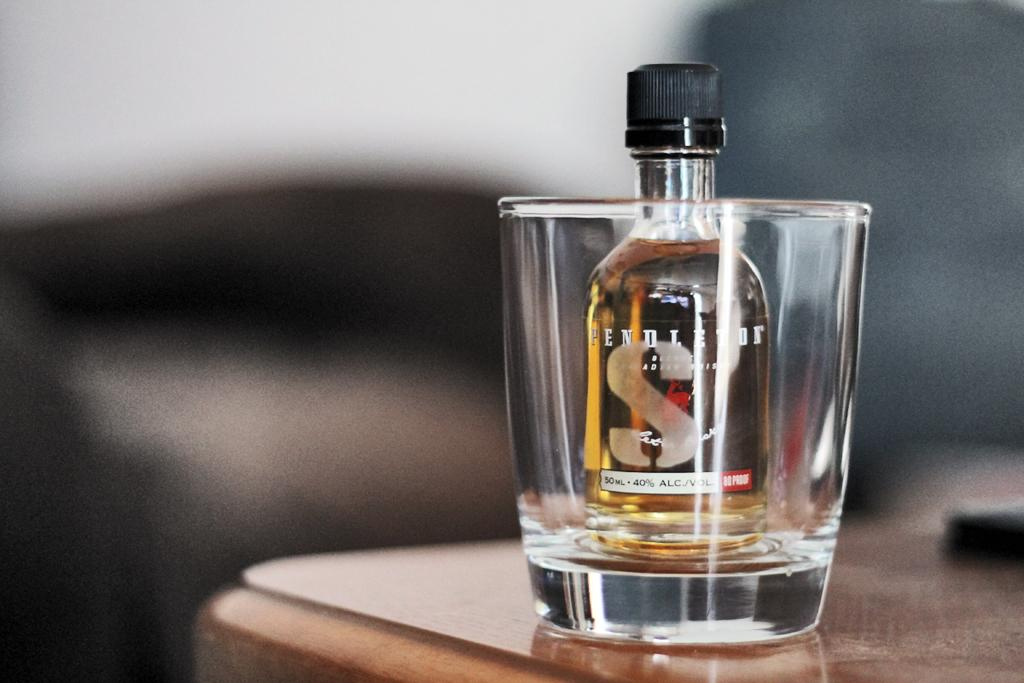What is inside the glass in the image? There is a bottle in the glass. Where is the glass located? The glass is on a table. What type of lumber is being used to build the parent's crib in the image? There is no parent, crib, or lumber present in the image; it only features a glass with a bottle inside and a table. 